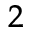<formula> <loc_0><loc_0><loc_500><loc_500>^ { 2 }</formula> 